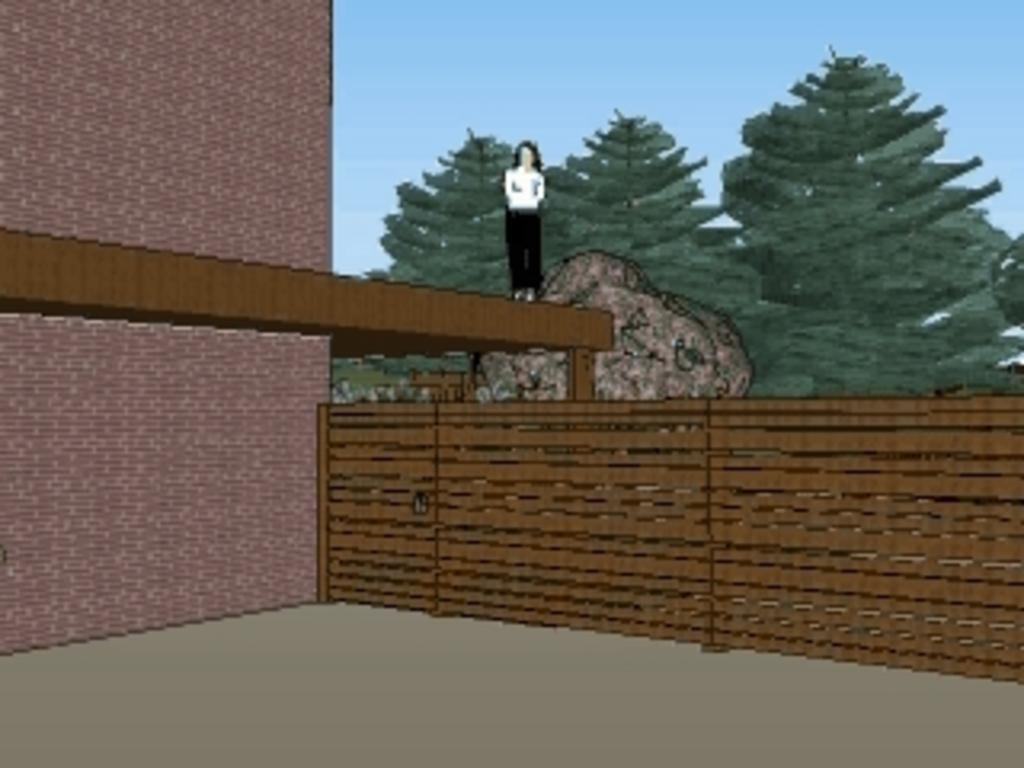What type of image is being described? The image appears to be an edited photo. What structure can be seen in the image? There is a building in the image. What type of barrier is present in the image? There is a fence in the image. What natural element is present in the image? There is a rock in the image. Who or what is present in the image? There is a person in the image. What type of vegetation is present in the image? There are trees in the image. What part of the natural environment is visible in the image? The sky is visible in the image. How many fairies are visible in the image? There are no fairies present in the image. What type of rings can be seen on the person's fingers in the image? There is no mention of rings or any jewelry on the person's fingers in the image. 